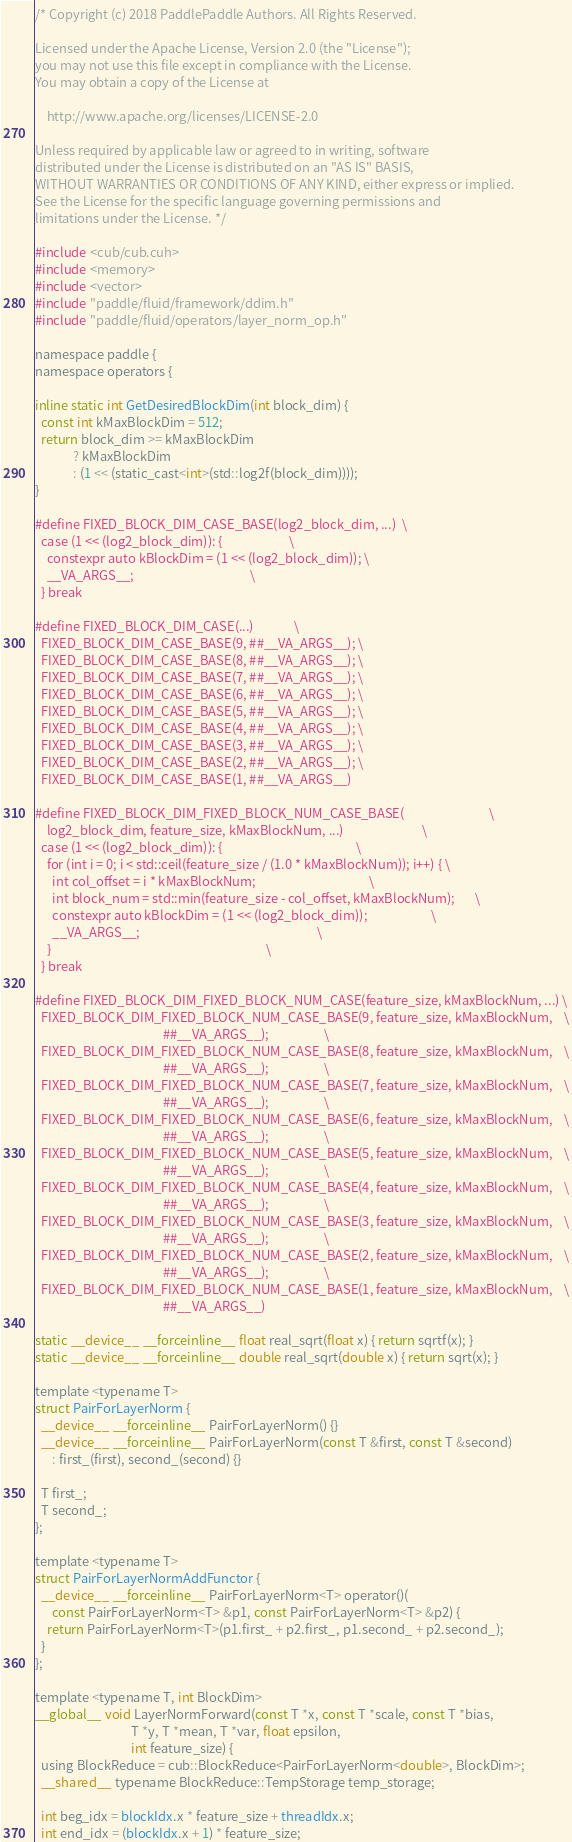Convert code to text. <code><loc_0><loc_0><loc_500><loc_500><_Cuda_>/* Copyright (c) 2018 PaddlePaddle Authors. All Rights Reserved.

Licensed under the Apache License, Version 2.0 (the "License");
you may not use this file except in compliance with the License.
You may obtain a copy of the License at

    http://www.apache.org/licenses/LICENSE-2.0

Unless required by applicable law or agreed to in writing, software
distributed under the License is distributed on an "AS IS" BASIS,
WITHOUT WARRANTIES OR CONDITIONS OF ANY KIND, either express or implied.
See the License for the specific language governing permissions and
limitations under the License. */

#include <cub/cub.cuh>
#include <memory>
#include <vector>
#include "paddle/fluid/framework/ddim.h"
#include "paddle/fluid/operators/layer_norm_op.h"

namespace paddle {
namespace operators {

inline static int GetDesiredBlockDim(int block_dim) {
  const int kMaxBlockDim = 512;
  return block_dim >= kMaxBlockDim
             ? kMaxBlockDim
             : (1 << (static_cast<int>(std::log2f(block_dim))));
}

#define FIXED_BLOCK_DIM_CASE_BASE(log2_block_dim, ...)  \
  case (1 << (log2_block_dim)): {                       \
    constexpr auto kBlockDim = (1 << (log2_block_dim)); \
    __VA_ARGS__;                                        \
  } break

#define FIXED_BLOCK_DIM_CASE(...)              \
  FIXED_BLOCK_DIM_CASE_BASE(9, ##__VA_ARGS__); \
  FIXED_BLOCK_DIM_CASE_BASE(8, ##__VA_ARGS__); \
  FIXED_BLOCK_DIM_CASE_BASE(7, ##__VA_ARGS__); \
  FIXED_BLOCK_DIM_CASE_BASE(6, ##__VA_ARGS__); \
  FIXED_BLOCK_DIM_CASE_BASE(5, ##__VA_ARGS__); \
  FIXED_BLOCK_DIM_CASE_BASE(4, ##__VA_ARGS__); \
  FIXED_BLOCK_DIM_CASE_BASE(3, ##__VA_ARGS__); \
  FIXED_BLOCK_DIM_CASE_BASE(2, ##__VA_ARGS__); \
  FIXED_BLOCK_DIM_CASE_BASE(1, ##__VA_ARGS__)

#define FIXED_BLOCK_DIM_FIXED_BLOCK_NUM_CASE_BASE(                             \
    log2_block_dim, feature_size, kMaxBlockNum, ...)                           \
  case (1 << (log2_block_dim)): {                                              \
    for (int i = 0; i < std::ceil(feature_size / (1.0 * kMaxBlockNum)); i++) { \
      int col_offset = i * kMaxBlockNum;                                       \
      int block_num = std::min(feature_size - col_offset, kMaxBlockNum);       \
      constexpr auto kBlockDim = (1 << (log2_block_dim));                      \
      __VA_ARGS__;                                                             \
    }                                                                          \
  } break

#define FIXED_BLOCK_DIM_FIXED_BLOCK_NUM_CASE(feature_size, kMaxBlockNum, ...) \
  FIXED_BLOCK_DIM_FIXED_BLOCK_NUM_CASE_BASE(9, feature_size, kMaxBlockNum,    \
                                            ##__VA_ARGS__);                   \
  FIXED_BLOCK_DIM_FIXED_BLOCK_NUM_CASE_BASE(8, feature_size, kMaxBlockNum,    \
                                            ##__VA_ARGS__);                   \
  FIXED_BLOCK_DIM_FIXED_BLOCK_NUM_CASE_BASE(7, feature_size, kMaxBlockNum,    \
                                            ##__VA_ARGS__);                   \
  FIXED_BLOCK_DIM_FIXED_BLOCK_NUM_CASE_BASE(6, feature_size, kMaxBlockNum,    \
                                            ##__VA_ARGS__);                   \
  FIXED_BLOCK_DIM_FIXED_BLOCK_NUM_CASE_BASE(5, feature_size, kMaxBlockNum,    \
                                            ##__VA_ARGS__);                   \
  FIXED_BLOCK_DIM_FIXED_BLOCK_NUM_CASE_BASE(4, feature_size, kMaxBlockNum,    \
                                            ##__VA_ARGS__);                   \
  FIXED_BLOCK_DIM_FIXED_BLOCK_NUM_CASE_BASE(3, feature_size, kMaxBlockNum,    \
                                            ##__VA_ARGS__);                   \
  FIXED_BLOCK_DIM_FIXED_BLOCK_NUM_CASE_BASE(2, feature_size, kMaxBlockNum,    \
                                            ##__VA_ARGS__);                   \
  FIXED_BLOCK_DIM_FIXED_BLOCK_NUM_CASE_BASE(1, feature_size, kMaxBlockNum,    \
                                            ##__VA_ARGS__)

static __device__ __forceinline__ float real_sqrt(float x) { return sqrtf(x); }
static __device__ __forceinline__ double real_sqrt(double x) { return sqrt(x); }

template <typename T>
struct PairForLayerNorm {
  __device__ __forceinline__ PairForLayerNorm() {}
  __device__ __forceinline__ PairForLayerNorm(const T &first, const T &second)
      : first_(first), second_(second) {}

  T first_;
  T second_;
};

template <typename T>
struct PairForLayerNormAddFunctor {
  __device__ __forceinline__ PairForLayerNorm<T> operator()(
      const PairForLayerNorm<T> &p1, const PairForLayerNorm<T> &p2) {
    return PairForLayerNorm<T>(p1.first_ + p2.first_, p1.second_ + p2.second_);
  }
};

template <typename T, int BlockDim>
__global__ void LayerNormForward(const T *x, const T *scale, const T *bias,
                                 T *y, T *mean, T *var, float epsilon,
                                 int feature_size) {
  using BlockReduce = cub::BlockReduce<PairForLayerNorm<double>, BlockDim>;
  __shared__ typename BlockReduce::TempStorage temp_storage;

  int beg_idx = blockIdx.x * feature_size + threadIdx.x;
  int end_idx = (blockIdx.x + 1) * feature_size;
</code> 